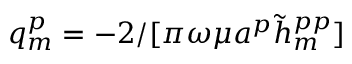Convert formula to latex. <formula><loc_0><loc_0><loc_500><loc_500>q _ { m } ^ { p } = - 2 / [ \pi \omega \mu a ^ { p } \tilde { h } _ { m } ^ { p p } ]</formula> 